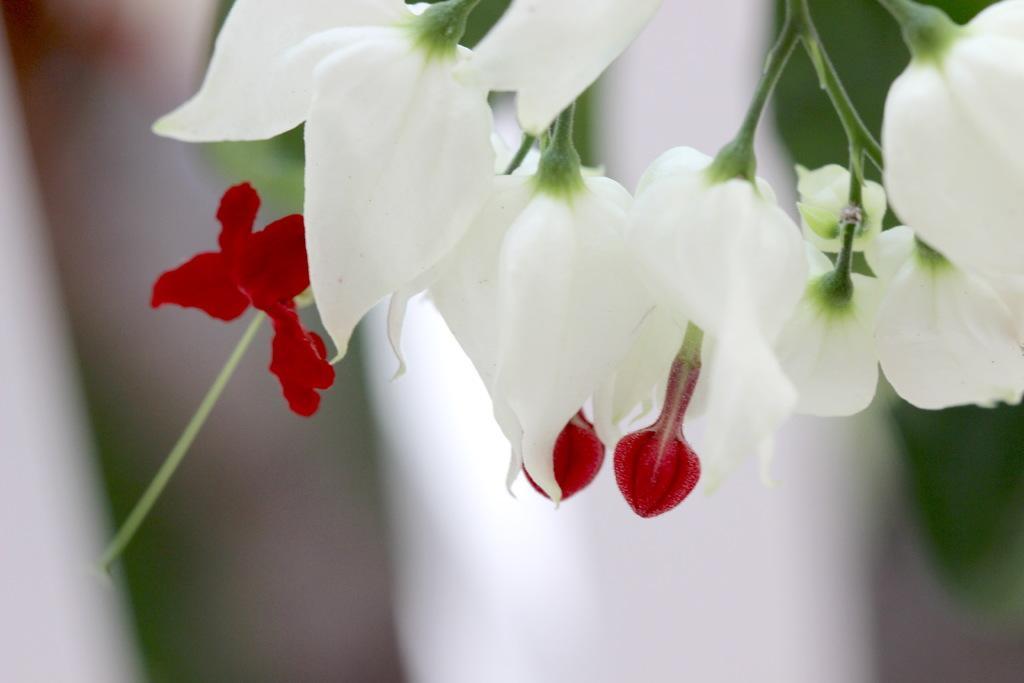Can you describe this image briefly? In this picture we can see flowers and in the background we can see it is blurry. 